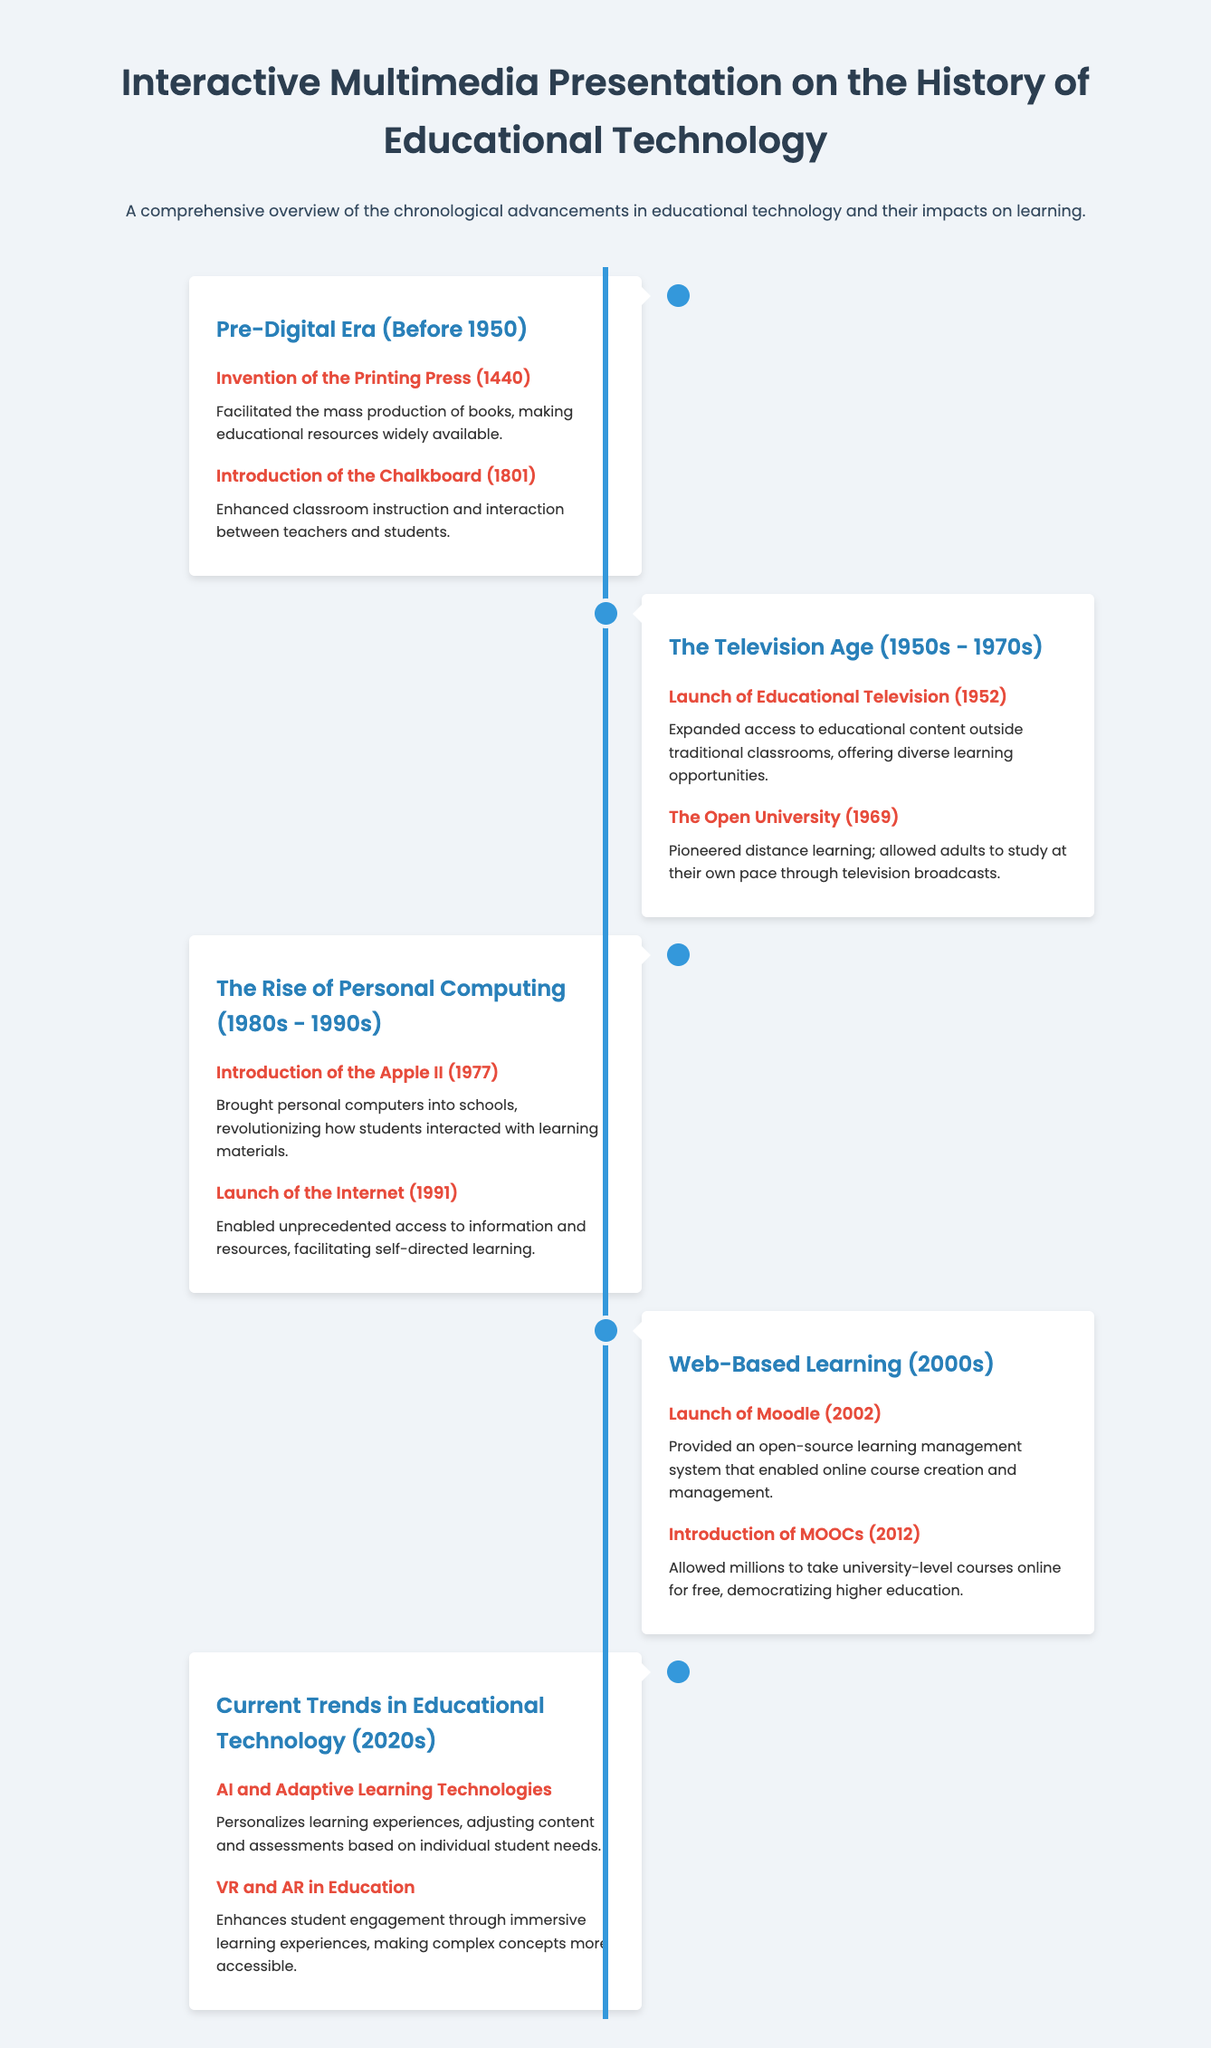What event occurred in 1440? The event in 1440 is the invention of the printing press, which facilitated mass production of books.
Answer: Invention of the printing press What new educational format was launched in 2012? The new educational format launched in 2012 is MOOCs, which allowed free access to university-level courses online.
Answer: MOOCs What technological advancement is associated with the years 2000s? The technological advancement associated with the 2000s is the launch of Moodle, an open-source learning management system.
Answer: Moodle Which device revolutionized learning interaction in schools during the 1980s? The device that revolutionized learning interaction in schools during the 1980s is the Apple II, introduced in 1977.
Answer: Apple II What are the current trends in educational technology as mentioned? The current trends in educational technology include AI and adaptive learning technologies and VR and AR in education.
Answer: AI and Adaptive Learning Technologies, VR and AR What was the primary impact of the introduction of the chalkboard in 1801? The introduction of the chalkboard enhanced classroom instruction and interaction between teachers and students.
Answer: Enhanced classroom instruction What major event took place in 1969? The major event in 1969 was the establishment of The Open University, which pioneered distance learning.
Answer: The Open University What percentage of the timeline covers the pre-digital era? The pre-digital era covers the timeline before 1950, which is approximately 20% of the total timeline.
Answer: Before 1950 What technology allows personalized learning experiences today? The technology allowing personalized learning experiences today is AI and adaptive learning technologies.
Answer: AI and adaptive learning technologies 